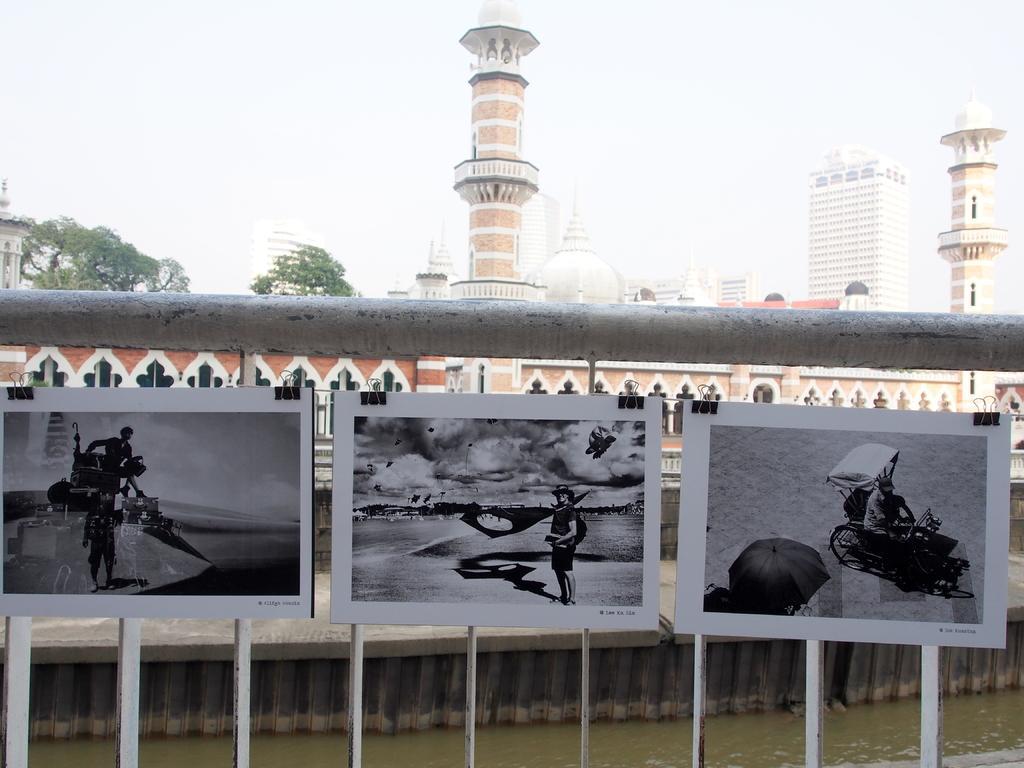How would you summarize this image in a sentence or two? In the image,there are total three boards each board have some black and white image on it,behind these images there is a big building and in the background there are some tall towers and sky. 